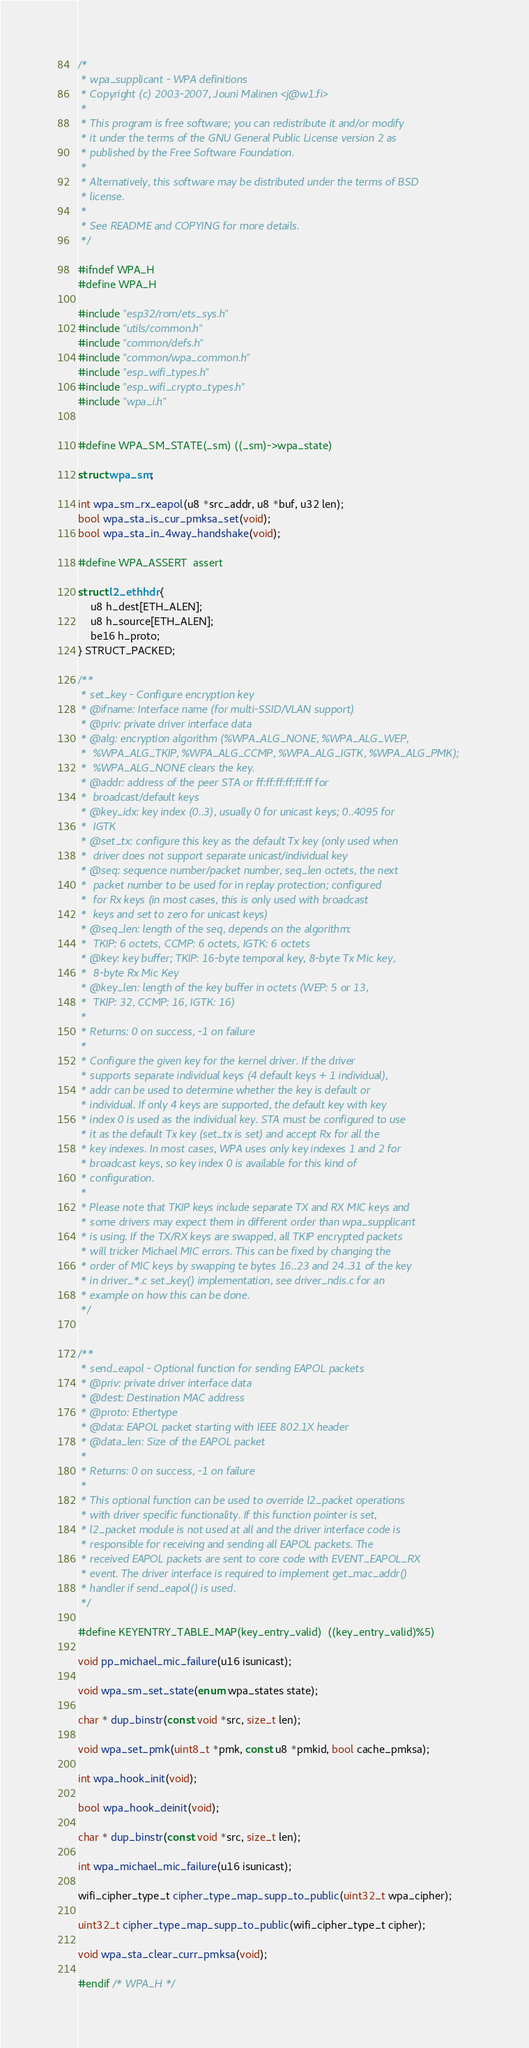Convert code to text. <code><loc_0><loc_0><loc_500><loc_500><_C_>/*
 * wpa_supplicant - WPA definitions
 * Copyright (c) 2003-2007, Jouni Malinen <j@w1.fi>
 *
 * This program is free software; you can redistribute it and/or modify
 * it under the terms of the GNU General Public License version 2 as
 * published by the Free Software Foundation.
 *
 * Alternatively, this software may be distributed under the terms of BSD
 * license.
 *
 * See README and COPYING for more details.
 */

#ifndef WPA_H
#define WPA_H

#include "esp32/rom/ets_sys.h"
#include "utils/common.h"
#include "common/defs.h"
#include "common/wpa_common.h"
#include "esp_wifi_types.h"
#include "esp_wifi_crypto_types.h"
#include "wpa_i.h"


#define WPA_SM_STATE(_sm) ((_sm)->wpa_state)

struct wpa_sm;

int wpa_sm_rx_eapol(u8 *src_addr, u8 *buf, u32 len);
bool wpa_sta_is_cur_pmksa_set(void);
bool wpa_sta_in_4way_handshake(void);

#define WPA_ASSERT  assert

struct l2_ethhdr {
    u8 h_dest[ETH_ALEN];
    u8 h_source[ETH_ALEN];
    be16 h_proto;
} STRUCT_PACKED;

/**
 * set_key - Configure encryption key
 * @ifname: Interface name (for multi-SSID/VLAN support)
 * @priv: private driver interface data
 * @alg: encryption algorithm (%WPA_ALG_NONE, %WPA_ALG_WEP,
 *	%WPA_ALG_TKIP, %WPA_ALG_CCMP, %WPA_ALG_IGTK, %WPA_ALG_PMK);
 *	%WPA_ALG_NONE clears the key.
 * @addr: address of the peer STA or ff:ff:ff:ff:ff:ff for
 *	broadcast/default keys
 * @key_idx: key index (0..3), usually 0 for unicast keys; 0..4095 for
 *	IGTK
 * @set_tx: configure this key as the default Tx key (only used when
 *	driver does not support separate unicast/individual key
 * @seq: sequence number/packet number, seq_len octets, the next
 *	packet number to be used for in replay protection; configured
 *	for Rx keys (in most cases, this is only used with broadcast
 *	keys and set to zero for unicast keys)
 * @seq_len: length of the seq, depends on the algorithm:
 *	TKIP: 6 octets, CCMP: 6 octets, IGTK: 6 octets
 * @key: key buffer; TKIP: 16-byte temporal key, 8-byte Tx Mic key,
 *	8-byte Rx Mic Key
 * @key_len: length of the key buffer in octets (WEP: 5 or 13,
 *	TKIP: 32, CCMP: 16, IGTK: 16)
 *
 * Returns: 0 on success, -1 on failure
 *
 * Configure the given key for the kernel driver. If the driver
 * supports separate individual keys (4 default keys + 1 individual),
 * addr can be used to determine whether the key is default or
 * individual. If only 4 keys are supported, the default key with key
 * index 0 is used as the individual key. STA must be configured to use
 * it as the default Tx key (set_tx is set) and accept Rx for all the
 * key indexes. In most cases, WPA uses only key indexes 1 and 2 for
 * broadcast keys, so key index 0 is available for this kind of
 * configuration.
 *
 * Please note that TKIP keys include separate TX and RX MIC keys and
 * some drivers may expect them in different order than wpa_supplicant
 * is using. If the TX/RX keys are swapped, all TKIP encrypted packets
 * will tricker Michael MIC errors. This can be fixed by changing the
 * order of MIC keys by swapping te bytes 16..23 and 24..31 of the key
 * in driver_*.c set_key() implementation, see driver_ndis.c for an
 * example on how this can be done.
 */


/**
 * send_eapol - Optional function for sending EAPOL packets
 * @priv: private driver interface data
 * @dest: Destination MAC address
 * @proto: Ethertype
 * @data: EAPOL packet starting with IEEE 802.1X header
 * @data_len: Size of the EAPOL packet
 *
 * Returns: 0 on success, -1 on failure
 *
 * This optional function can be used to override l2_packet operations
 * with driver specific functionality. If this function pointer is set,
 * l2_packet module is not used at all and the driver interface code is
 * responsible for receiving and sending all EAPOL packets. The
 * received EAPOL packets are sent to core code with EVENT_EAPOL_RX
 * event. The driver interface is required to implement get_mac_addr()
 * handler if send_eapol() is used.
 */

#define KEYENTRY_TABLE_MAP(key_entry_valid)  ((key_entry_valid)%5) 

void pp_michael_mic_failure(u16 isunicast);

void wpa_sm_set_state(enum wpa_states state);

char * dup_binstr(const void *src, size_t len);

void wpa_set_pmk(uint8_t *pmk, const u8 *pmkid, bool cache_pmksa);

int wpa_hook_init(void);

bool wpa_hook_deinit(void);

char * dup_binstr(const void *src, size_t len);

int wpa_michael_mic_failure(u16 isunicast);

wifi_cipher_type_t cipher_type_map_supp_to_public(uint32_t wpa_cipher);

uint32_t cipher_type_map_supp_to_public(wifi_cipher_type_t cipher);

void wpa_sta_clear_curr_pmksa(void);

#endif /* WPA_H */

</code> 